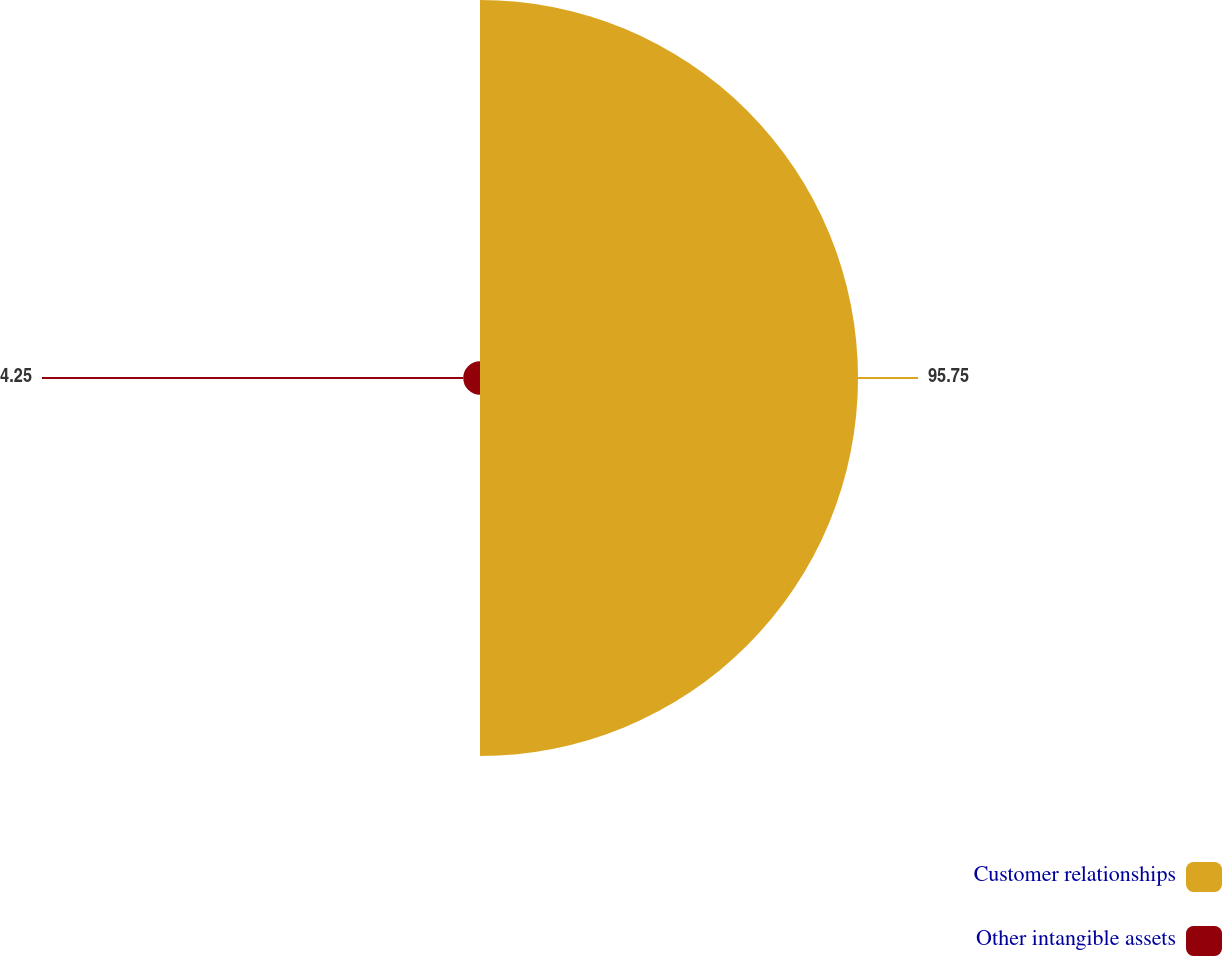Convert chart to OTSL. <chart><loc_0><loc_0><loc_500><loc_500><pie_chart><fcel>Customer relationships<fcel>Other intangible assets<nl><fcel>95.75%<fcel>4.25%<nl></chart> 